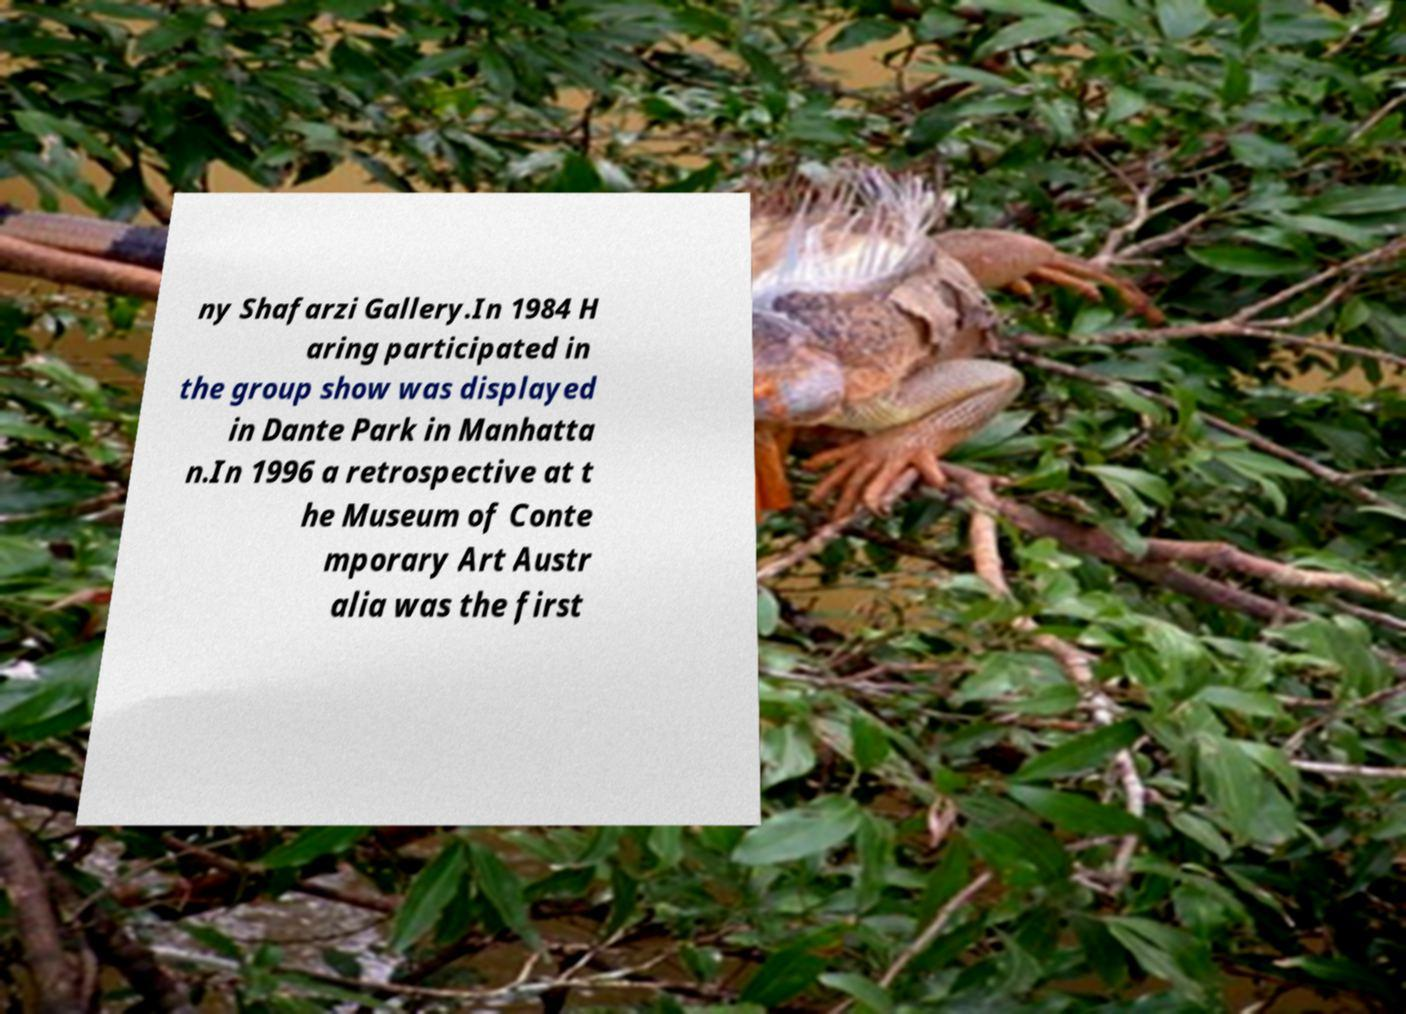Could you assist in decoding the text presented in this image and type it out clearly? ny Shafarzi Gallery.In 1984 H aring participated in the group show was displayed in Dante Park in Manhatta n.In 1996 a retrospective at t he Museum of Conte mporary Art Austr alia was the first 